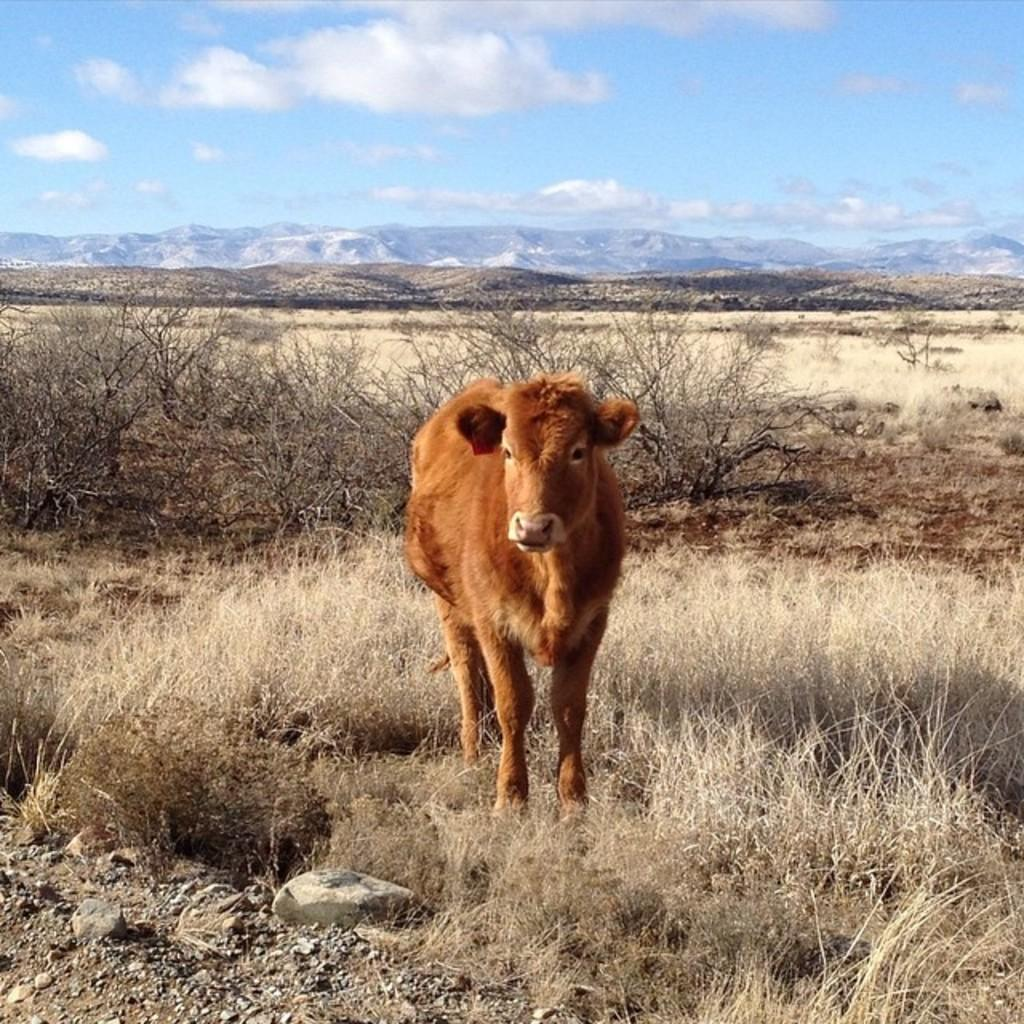What type of animal is in the image? There is a calf in the image. What color is the calf? The calf is brown in color. What can be seen in the background of the image? There are trees visible in the image. How would you describe the sky in the image? The sky is cloudy in the image. How many brothers does the calf have in the image? There is no information about the calf's brothers in the image. What type of health issues does the calf have in the image? There is no information about the calf's health in the image. 